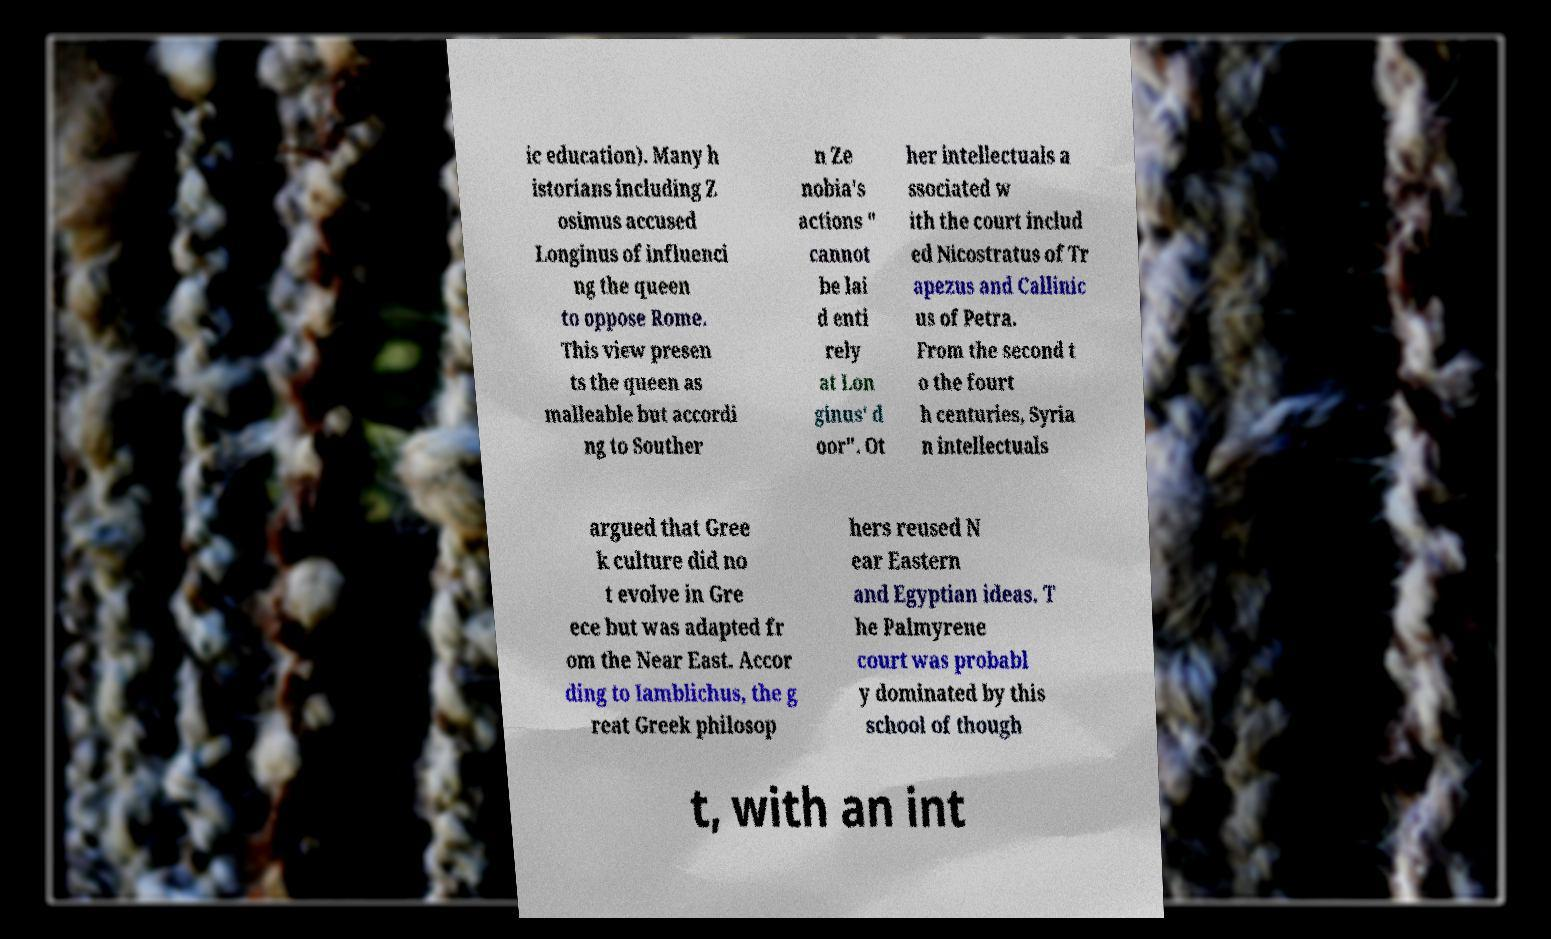Please identify and transcribe the text found in this image. ic education). Many h istorians including Z osimus accused Longinus of influenci ng the queen to oppose Rome. This view presen ts the queen as malleable but accordi ng to Souther n Ze nobia's actions " cannot be lai d enti rely at Lon ginus' d oor". Ot her intellectuals a ssociated w ith the court includ ed Nicostratus of Tr apezus and Callinic us of Petra. From the second t o the fourt h centuries, Syria n intellectuals argued that Gree k culture did no t evolve in Gre ece but was adapted fr om the Near East. Accor ding to Iamblichus, the g reat Greek philosop hers reused N ear Eastern and Egyptian ideas. T he Palmyrene court was probabl y dominated by this school of though t, with an int 